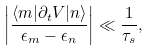<formula> <loc_0><loc_0><loc_500><loc_500>\left | \frac { \langle m | \partial _ { t } V | n \rangle } { \epsilon _ { m } - \epsilon _ { n } } \right | \ll \frac { 1 } { \tau _ { s } } ,</formula> 